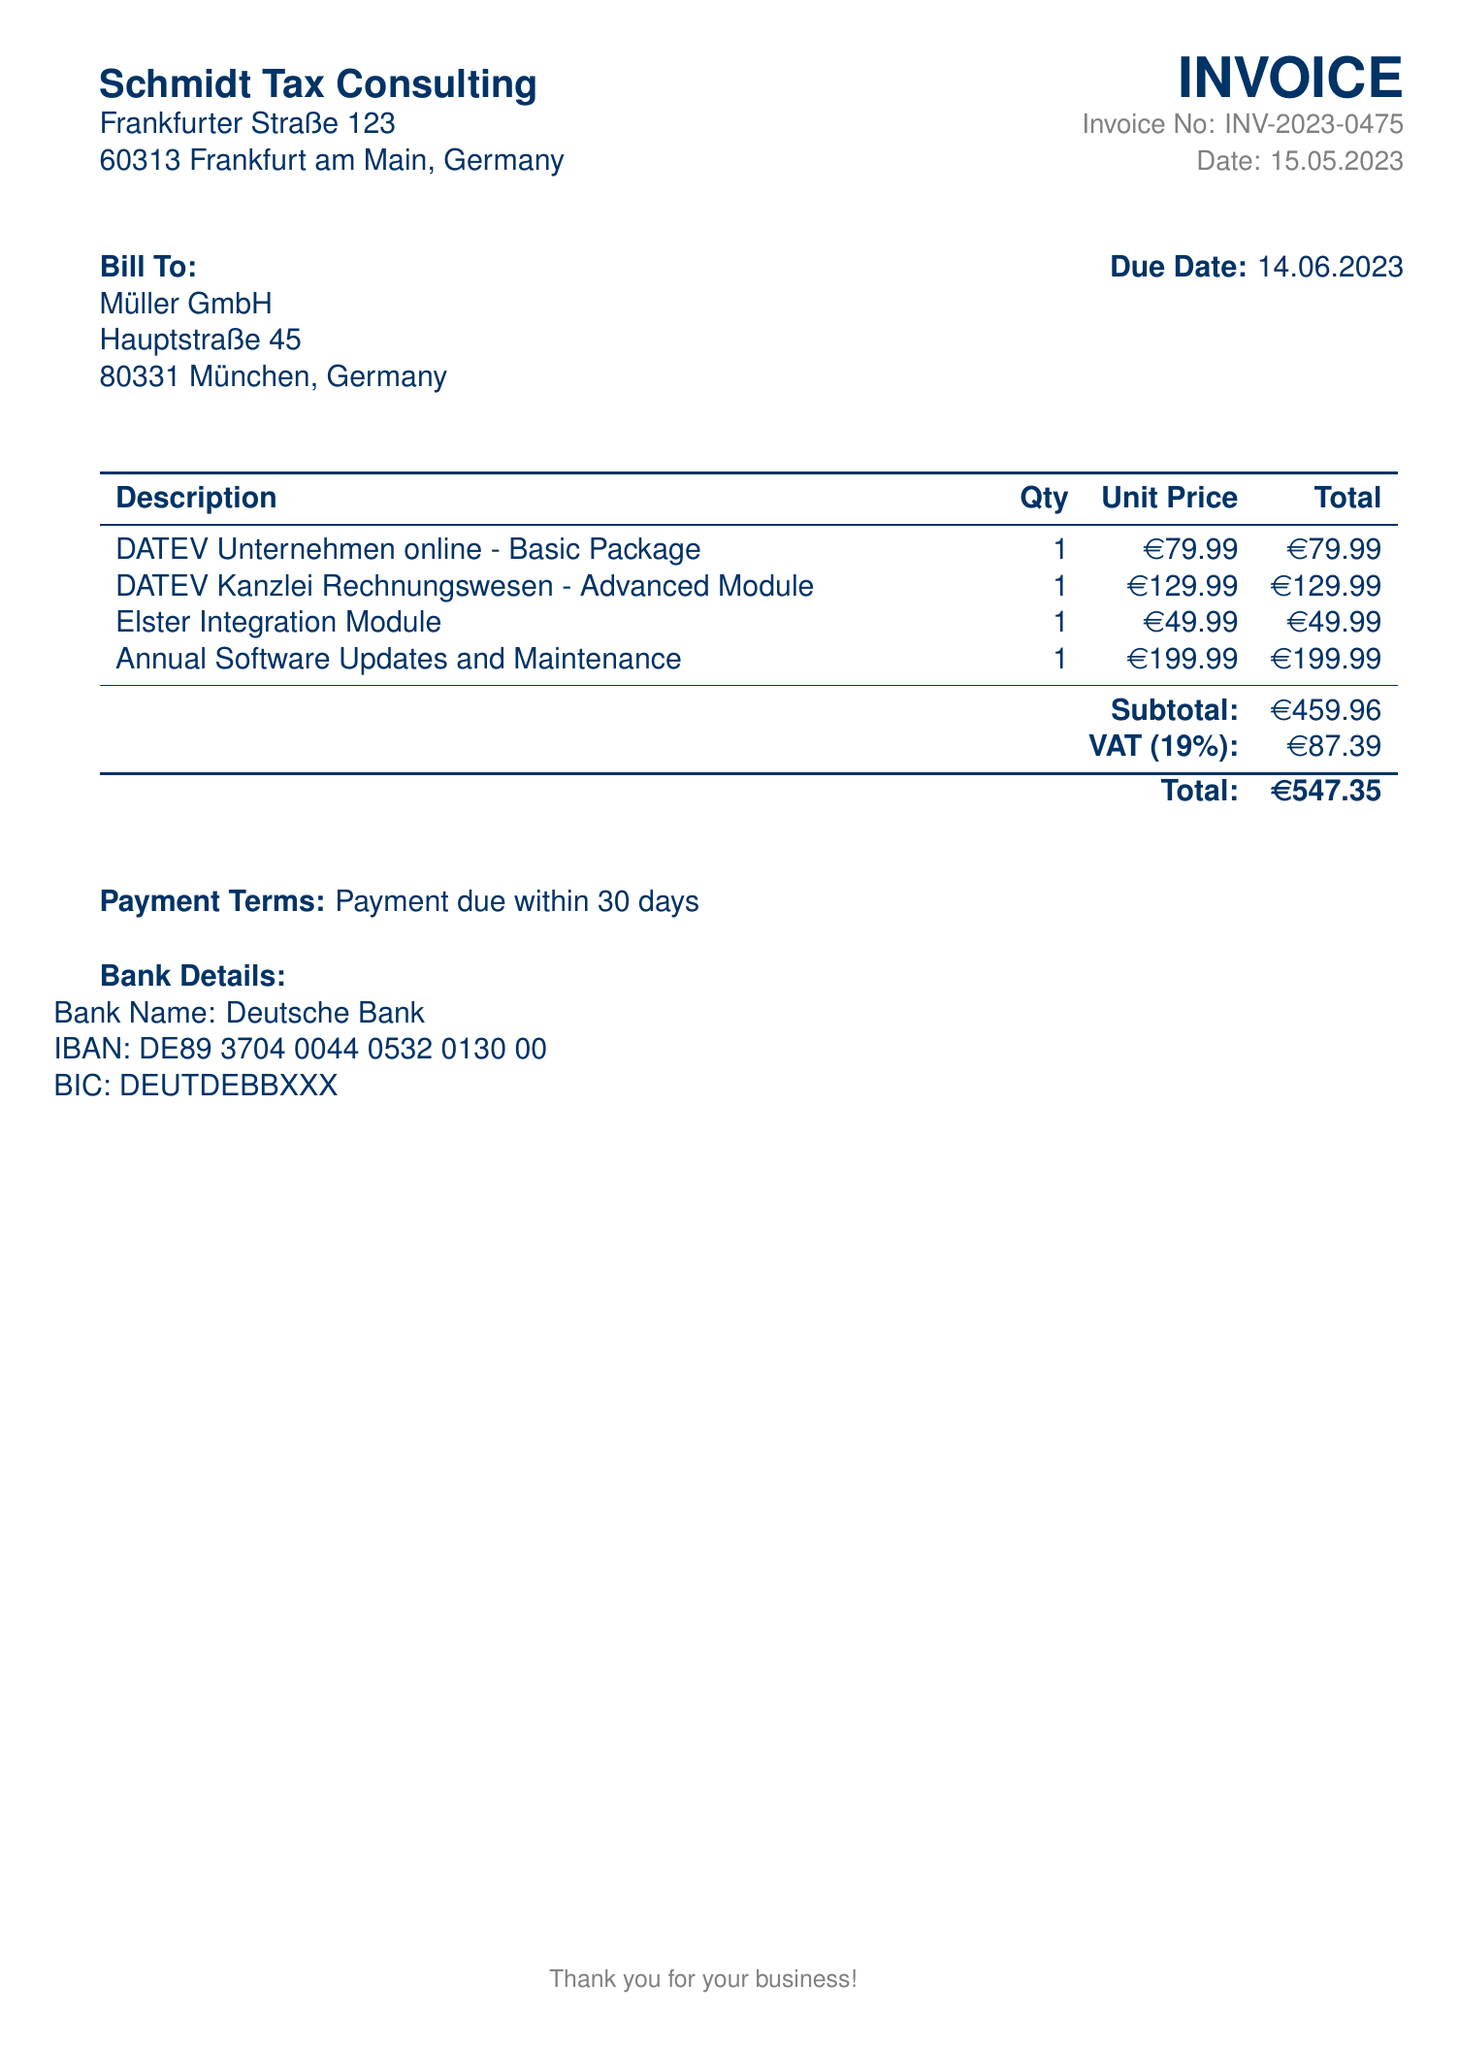What is the invoice number? The invoice number is specified in the document for reference, noted as INV-2023-0475.
Answer: INV-2023-0475 What is the total amount due? The total amount due is provided at the bottom of the invoice, which includes subtotal and VAT.
Answer: €547.35 When is the payment due? The document states the payment terms, indicating the payment is due within 30 days of the invoice date, which is 14.06.2023.
Answer: 14.06.2023 What is the cost of the Annual Software Updates and Maintenance? This specific module's cost is listed under the description and includes its unit price.
Answer: €199.99 How much is the VAT applied to the total? The invoice shows the VAT calculated at 19% of the subtotal.
Answer: €87.39 What is the name of the bank? The bank details section provides the name of the bank for payments, which is specified in the document.
Answer: Deutsche Bank What is the unit price of the DATEV Kanzlei Rechnungswesen - Advanced Module? The invoice lists the cost per unit for this module specifically within the table of modules and prices.
Answer: €129.99 How many modules are included in this invoice? The document lists several modules in the breakdown section, indicating the variety included.
Answer: 4 What is the description of the first listed item? The description provides the name of the first product in the modular breakdown of costs.
Answer: DATEV Unternehmen online - Basic Package 